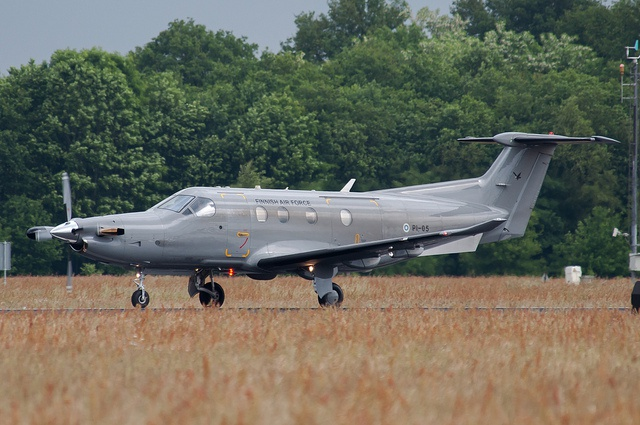Describe the objects in this image and their specific colors. I can see a airplane in darkgray, gray, black, and lightgray tones in this image. 